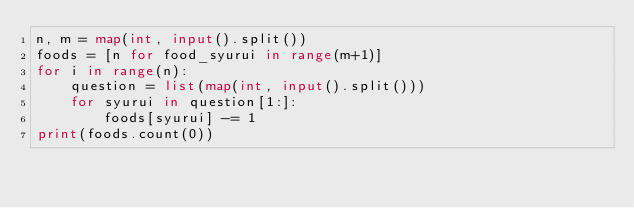<code> <loc_0><loc_0><loc_500><loc_500><_Python_>n, m = map(int, input().split())
foods = [n for food_syurui in range(m+1)]
for i in range(n):
	question = list(map(int, input().split()))
	for syurui in question[1:]:
		foods[syurui] -= 1
print(foods.count(0))</code> 